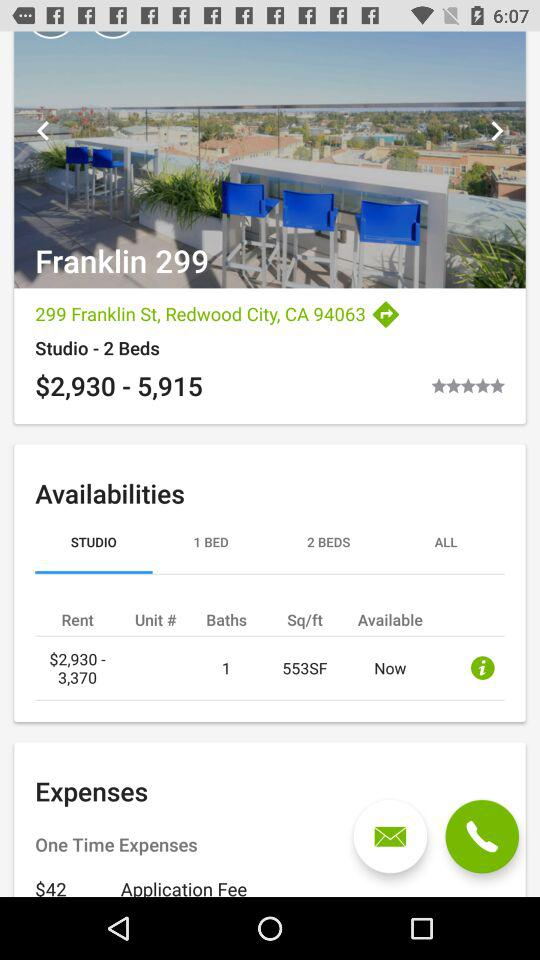What is the rent? The rent ranges from $2,930 to $3,370. 